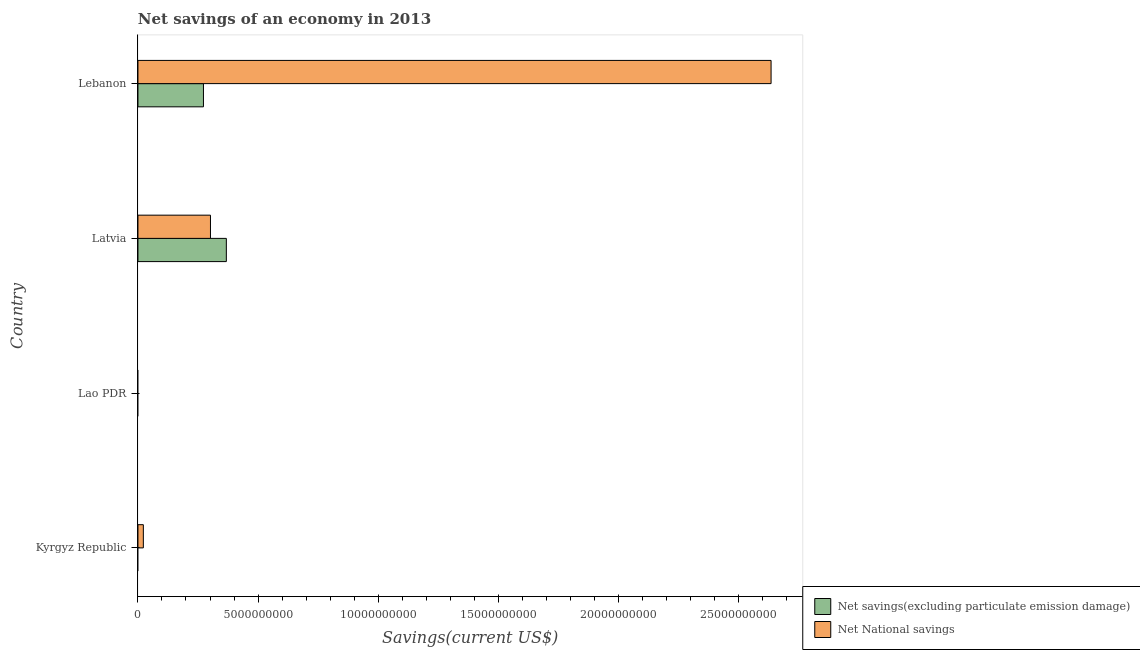How many different coloured bars are there?
Ensure brevity in your answer.  2. Are the number of bars per tick equal to the number of legend labels?
Give a very brief answer. No. How many bars are there on the 1st tick from the top?
Give a very brief answer. 2. How many bars are there on the 3rd tick from the bottom?
Offer a terse response. 2. What is the label of the 2nd group of bars from the top?
Your answer should be very brief. Latvia. What is the net national savings in Lebanon?
Ensure brevity in your answer.  2.64e+1. Across all countries, what is the maximum net national savings?
Offer a terse response. 2.64e+1. In which country was the net national savings maximum?
Keep it short and to the point. Lebanon. What is the total net savings(excluding particulate emission damage) in the graph?
Provide a short and direct response. 6.41e+09. What is the difference between the net national savings in Kyrgyz Republic and that in Lebanon?
Your response must be concise. -2.61e+1. What is the difference between the net national savings in Kyrgyz Republic and the net savings(excluding particulate emission damage) in Lebanon?
Provide a short and direct response. -2.50e+09. What is the average net national savings per country?
Provide a succinct answer. 7.40e+09. What is the difference between the net savings(excluding particulate emission damage) and net national savings in Latvia?
Keep it short and to the point. 6.61e+08. What is the ratio of the net national savings in Latvia to that in Lebanon?
Offer a very short reply. 0.12. Is the difference between the net savings(excluding particulate emission damage) in Latvia and Lebanon greater than the difference between the net national savings in Latvia and Lebanon?
Provide a short and direct response. Yes. What is the difference between the highest and the second highest net national savings?
Offer a terse response. 2.33e+1. What is the difference between the highest and the lowest net national savings?
Provide a short and direct response. 2.64e+1. How many bars are there?
Make the answer very short. 5. Are all the bars in the graph horizontal?
Make the answer very short. Yes. How many countries are there in the graph?
Your answer should be compact. 4. Are the values on the major ticks of X-axis written in scientific E-notation?
Your answer should be compact. No. Does the graph contain grids?
Keep it short and to the point. No. Where does the legend appear in the graph?
Ensure brevity in your answer.  Bottom right. What is the title of the graph?
Offer a very short reply. Net savings of an economy in 2013. Does "Methane emissions" appear as one of the legend labels in the graph?
Keep it short and to the point. No. What is the label or title of the X-axis?
Your answer should be very brief. Savings(current US$). What is the label or title of the Y-axis?
Your answer should be compact. Country. What is the Savings(current US$) in Net National savings in Kyrgyz Republic?
Offer a terse response. 2.24e+08. What is the Savings(current US$) of Net National savings in Lao PDR?
Offer a terse response. 0. What is the Savings(current US$) in Net savings(excluding particulate emission damage) in Latvia?
Your answer should be very brief. 3.68e+09. What is the Savings(current US$) of Net National savings in Latvia?
Your answer should be compact. 3.02e+09. What is the Savings(current US$) of Net savings(excluding particulate emission damage) in Lebanon?
Your response must be concise. 2.73e+09. What is the Savings(current US$) of Net National savings in Lebanon?
Offer a terse response. 2.64e+1. Across all countries, what is the maximum Savings(current US$) in Net savings(excluding particulate emission damage)?
Keep it short and to the point. 3.68e+09. Across all countries, what is the maximum Savings(current US$) of Net National savings?
Provide a succinct answer. 2.64e+1. What is the total Savings(current US$) of Net savings(excluding particulate emission damage) in the graph?
Ensure brevity in your answer.  6.41e+09. What is the total Savings(current US$) in Net National savings in the graph?
Keep it short and to the point. 2.96e+1. What is the difference between the Savings(current US$) in Net National savings in Kyrgyz Republic and that in Latvia?
Give a very brief answer. -2.80e+09. What is the difference between the Savings(current US$) in Net National savings in Kyrgyz Republic and that in Lebanon?
Keep it short and to the point. -2.61e+1. What is the difference between the Savings(current US$) of Net savings(excluding particulate emission damage) in Latvia and that in Lebanon?
Give a very brief answer. 9.54e+08. What is the difference between the Savings(current US$) of Net National savings in Latvia and that in Lebanon?
Your response must be concise. -2.33e+1. What is the difference between the Savings(current US$) of Net savings(excluding particulate emission damage) in Latvia and the Savings(current US$) of Net National savings in Lebanon?
Provide a succinct answer. -2.27e+1. What is the average Savings(current US$) in Net savings(excluding particulate emission damage) per country?
Offer a terse response. 1.60e+09. What is the average Savings(current US$) of Net National savings per country?
Make the answer very short. 7.40e+09. What is the difference between the Savings(current US$) of Net savings(excluding particulate emission damage) and Savings(current US$) of Net National savings in Latvia?
Offer a very short reply. 6.61e+08. What is the difference between the Savings(current US$) in Net savings(excluding particulate emission damage) and Savings(current US$) in Net National savings in Lebanon?
Provide a succinct answer. -2.36e+1. What is the ratio of the Savings(current US$) in Net National savings in Kyrgyz Republic to that in Latvia?
Your response must be concise. 0.07. What is the ratio of the Savings(current US$) of Net National savings in Kyrgyz Republic to that in Lebanon?
Your answer should be compact. 0.01. What is the ratio of the Savings(current US$) of Net savings(excluding particulate emission damage) in Latvia to that in Lebanon?
Provide a succinct answer. 1.35. What is the ratio of the Savings(current US$) in Net National savings in Latvia to that in Lebanon?
Provide a succinct answer. 0.11. What is the difference between the highest and the second highest Savings(current US$) in Net National savings?
Offer a very short reply. 2.33e+1. What is the difference between the highest and the lowest Savings(current US$) of Net savings(excluding particulate emission damage)?
Keep it short and to the point. 3.68e+09. What is the difference between the highest and the lowest Savings(current US$) in Net National savings?
Make the answer very short. 2.64e+1. 